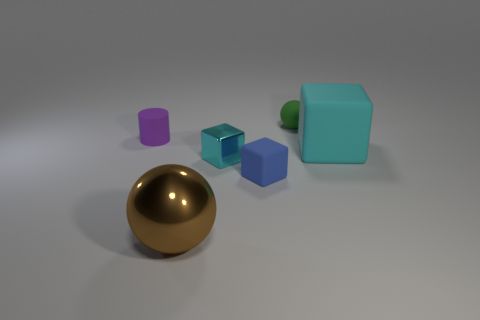Add 1 tiny purple things. How many objects exist? 7 Subtract all cylinders. How many objects are left? 5 Add 4 purple shiny cylinders. How many purple shiny cylinders exist? 4 Subtract 0 gray cubes. How many objects are left? 6 Subtract all small red matte things. Subtract all metallic cubes. How many objects are left? 5 Add 4 tiny blue matte things. How many tiny blue matte things are left? 5 